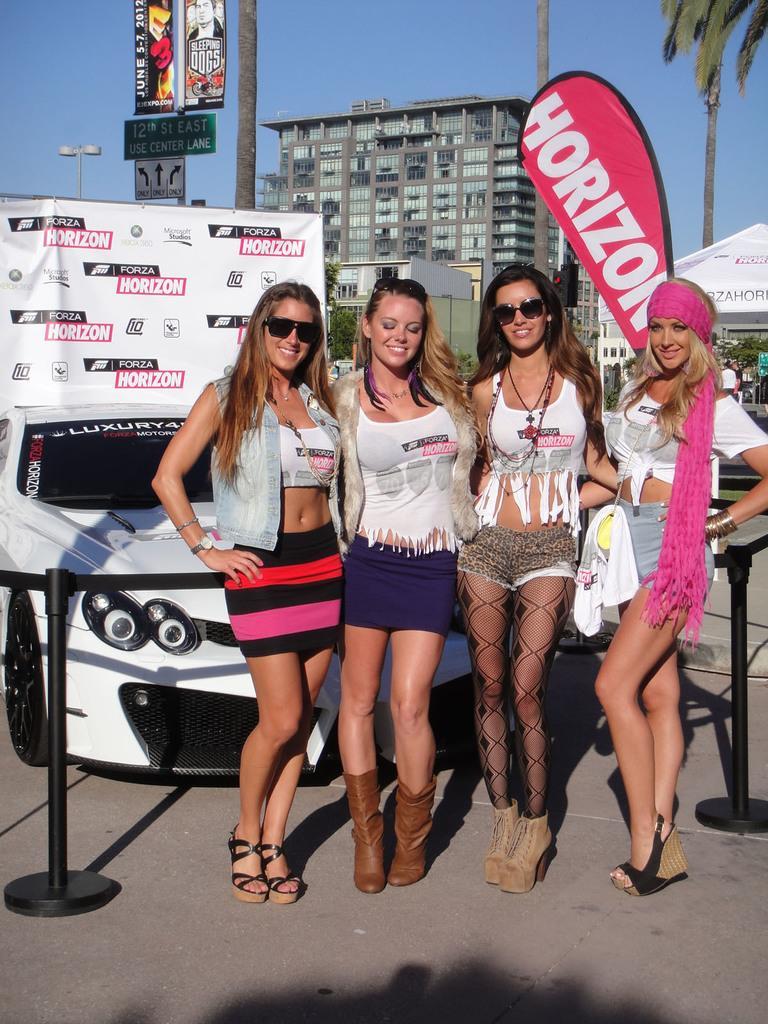Can you describe this image briefly? This image consists of four women standing in the front. At the bottom, there is a road. Behind them, there is a car in white color along with a banner. In the background, we can see a building. On the right, there is a tree along with a tent. At the top, there is sky. On the left, there are boards. 